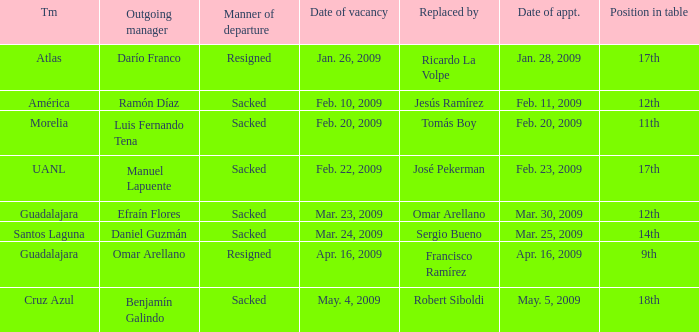What is Position in Table, when Replaced By is "Sergio Bueno"? 14th. 